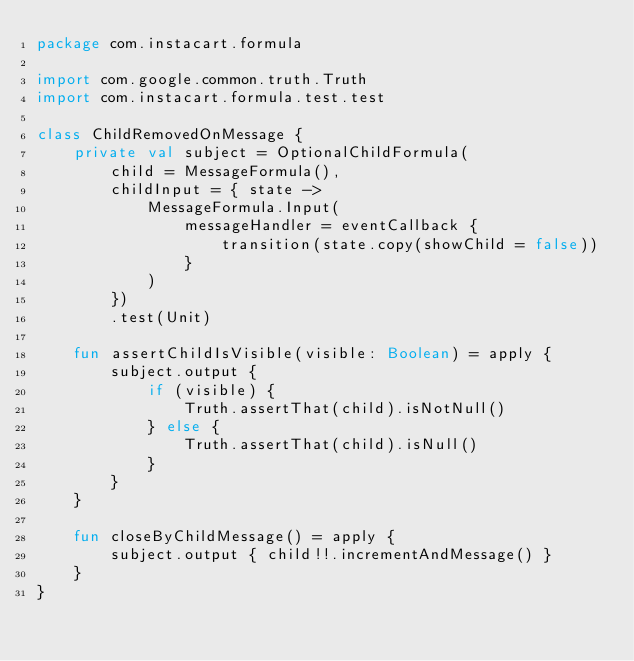<code> <loc_0><loc_0><loc_500><loc_500><_Kotlin_>package com.instacart.formula

import com.google.common.truth.Truth
import com.instacart.formula.test.test

class ChildRemovedOnMessage {
    private val subject = OptionalChildFormula(
        child = MessageFormula(),
        childInput = { state ->
            MessageFormula.Input(
                messageHandler = eventCallback {
                    transition(state.copy(showChild = false))
                }
            )
        })
        .test(Unit)

    fun assertChildIsVisible(visible: Boolean) = apply {
        subject.output {
            if (visible) {
                Truth.assertThat(child).isNotNull()
            } else {
                Truth.assertThat(child).isNull()
            }
        }
    }

    fun closeByChildMessage() = apply {
        subject.output { child!!.incrementAndMessage() }
    }
}
</code> 